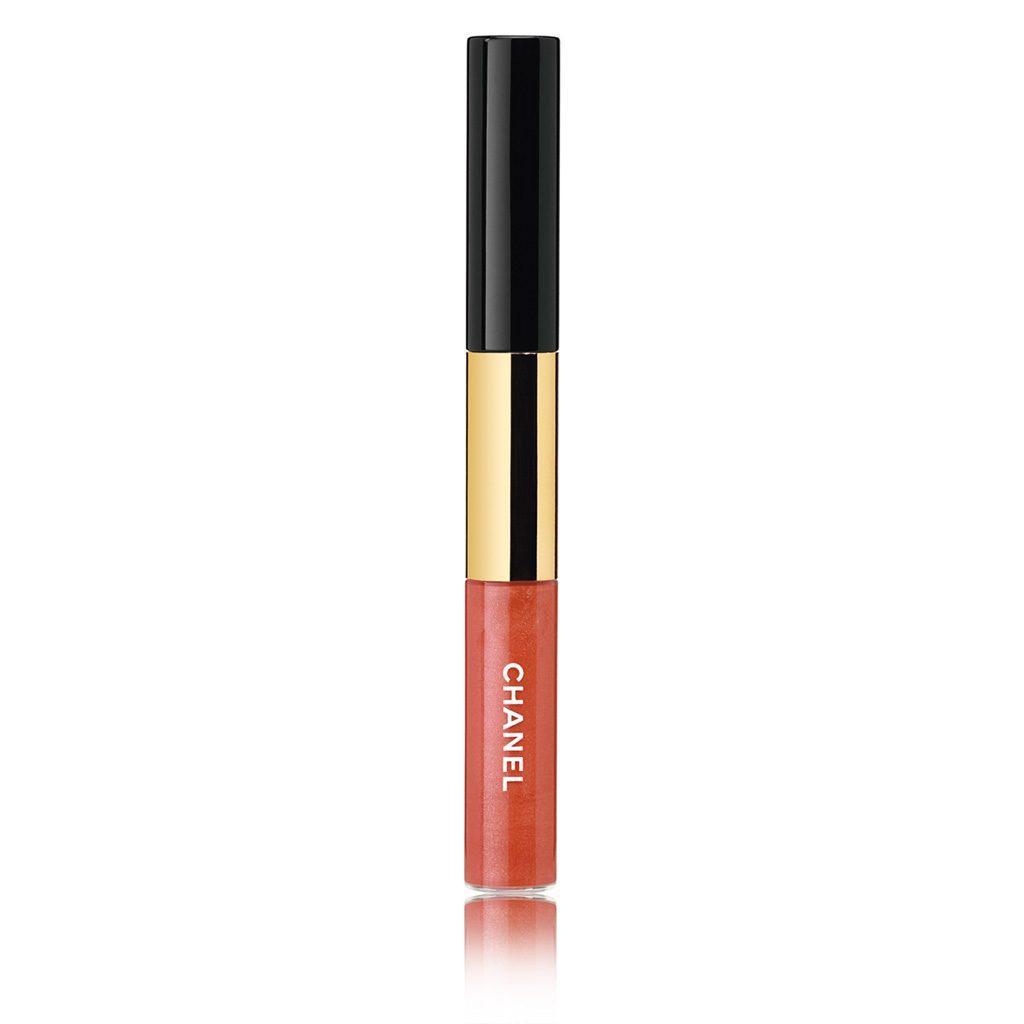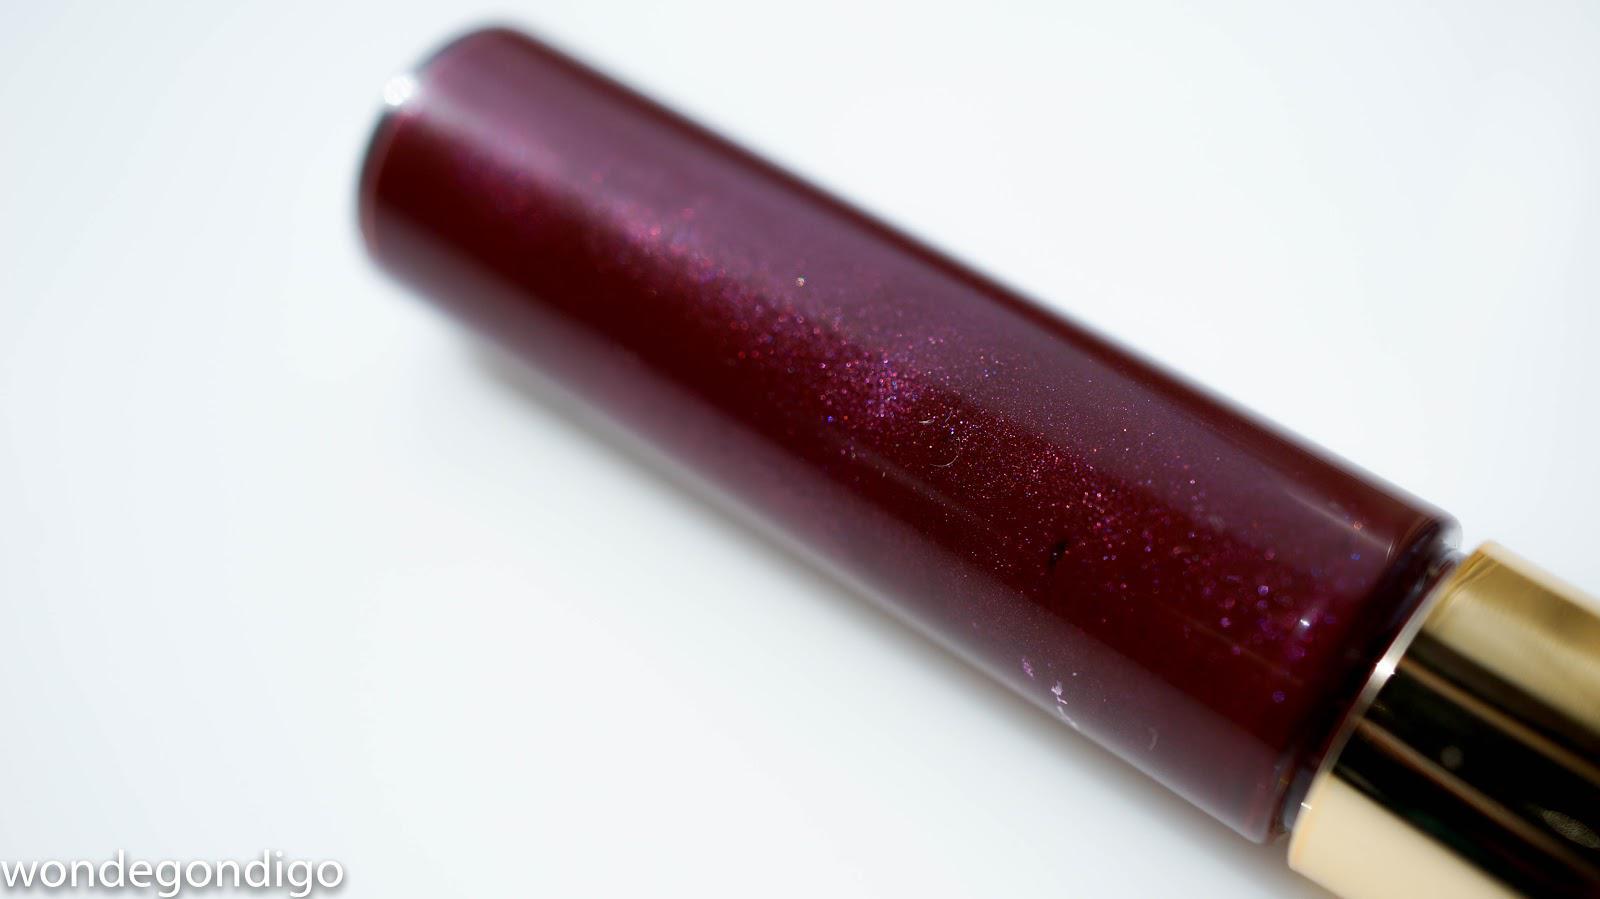The first image is the image on the left, the second image is the image on the right. Considering the images on both sides, is "There are two tubes of lipstick, and one of them is open while the other one is closed." valid? Answer yes or no. No. The first image is the image on the left, the second image is the image on the right. Given the left and right images, does the statement "Left image contains one lipstick with its applicator resting atop its base, and the right image shows one lipstick with its cap on." hold true? Answer yes or no. No. 